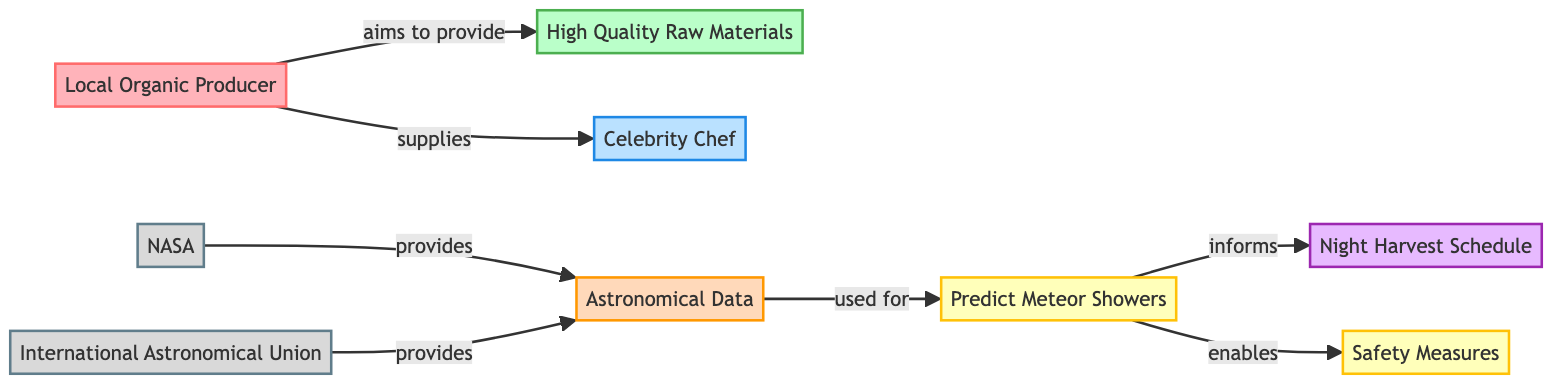What is the main goal of the Local Organic Producer? The diagram indicates that the main goal of the Local Organic Producer is to provide "High Quality Raw Materials". This is directly linked from the Local Organic Producer node to the High Quality Raw Materials node.
Answer: High Quality Raw Materials Who provides Astronomical Data? The diagram shows that both "NASA" and "International Astronomical Union" provide "Astronomical Data". This can be observed as both of these organizations are connected to the Astronomical Data node.
Answer: NASA and International Astronomical Union What action does predicting meteor showers enable? From the diagram, predicting meteor showers directly connects to "Safety Measures", which indicates that this action enables safety precautions while harvesting at night.
Answer: Safety Measures How does the Local Organic Producer interact with the Celebrity Chef? The interaction is indicated by the arrow labeled "supplies", which shows the Local Organic Producer supplying the Celebrity Chef with goods. This direct connection signifies a supply relationship between these two nodes.
Answer: supplies What informs the Night Harvest Schedule? The diagram indicates that "Predict Meteor Showers" informs the "Night Harvest Schedule". This means that the information from predicting meteor showers is essential for scheduling night harvesting activities safely.
Answer: Predict Meteor Showers How many organizations provide Astronomical Data? The diagram displays two organizations, NASA and the International Astronomical Union, connected to the Astronomical Data node. Therefore, the total count of organizations providing this data is two.
Answer: 2 What is the role of Predicting Meteor Showers in the diagram? The "Predict Meteor Showers" node has a dual role in the diagram: it informs the "Night Harvest Schedule" and enables "Safety Measures". Thus, it serves crucial functionalities related to both harvesting and safety.
Answer: informs and enables Which two nodes are connected by the action of "aims to provide"? The action "aims to provide" connects the "Local Organic Producer" node to the "High Quality Raw Materials" node. This connection details the intent of the producer towards quality ingredients.
Answer: Local Organic Producer and High Quality Raw Materials What does the Local Organic Producer aim to provide? From the diagram, the Local Organic Producer aims to provide "High Quality Raw Materials", indicating a commitment to quality in the ingredients they supply.
Answer: High Quality Raw Materials 